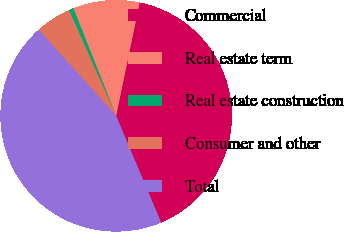Convert chart. <chart><loc_0><loc_0><loc_500><loc_500><pie_chart><fcel>Commercial<fcel>Real estate term<fcel>Real estate construction<fcel>Consumer and other<fcel>Total<nl><fcel>40.39%<fcel>9.28%<fcel>0.66%<fcel>4.97%<fcel>44.7%<nl></chart> 